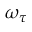<formula> <loc_0><loc_0><loc_500><loc_500>\omega _ { \tau }</formula> 